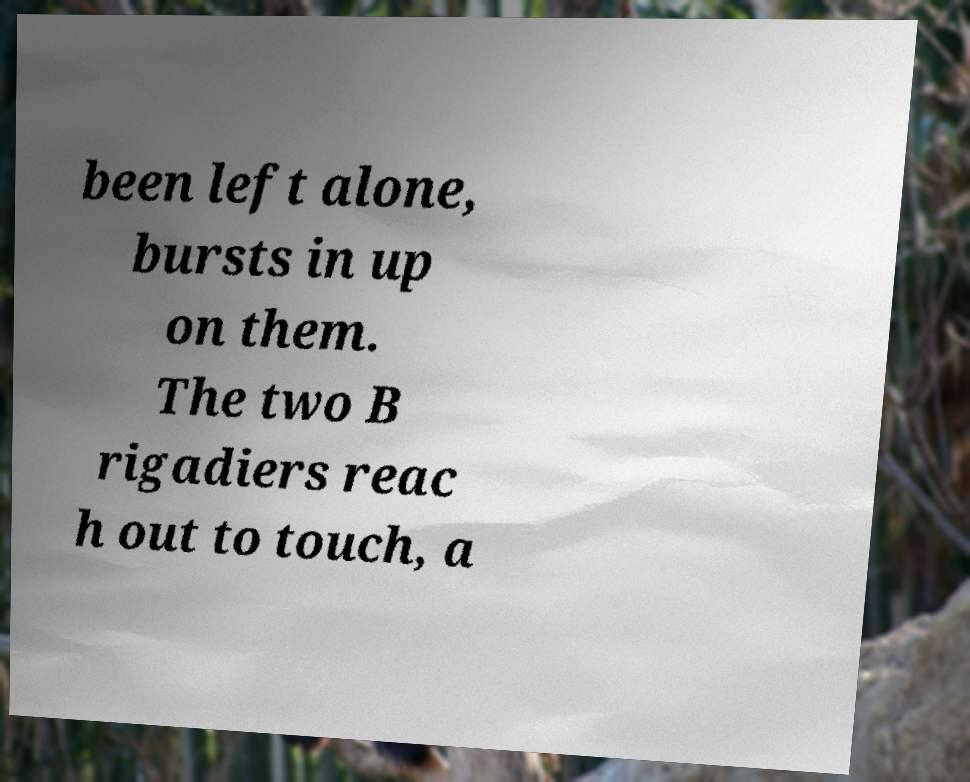For documentation purposes, I need the text within this image transcribed. Could you provide that? been left alone, bursts in up on them. The two B rigadiers reac h out to touch, a 